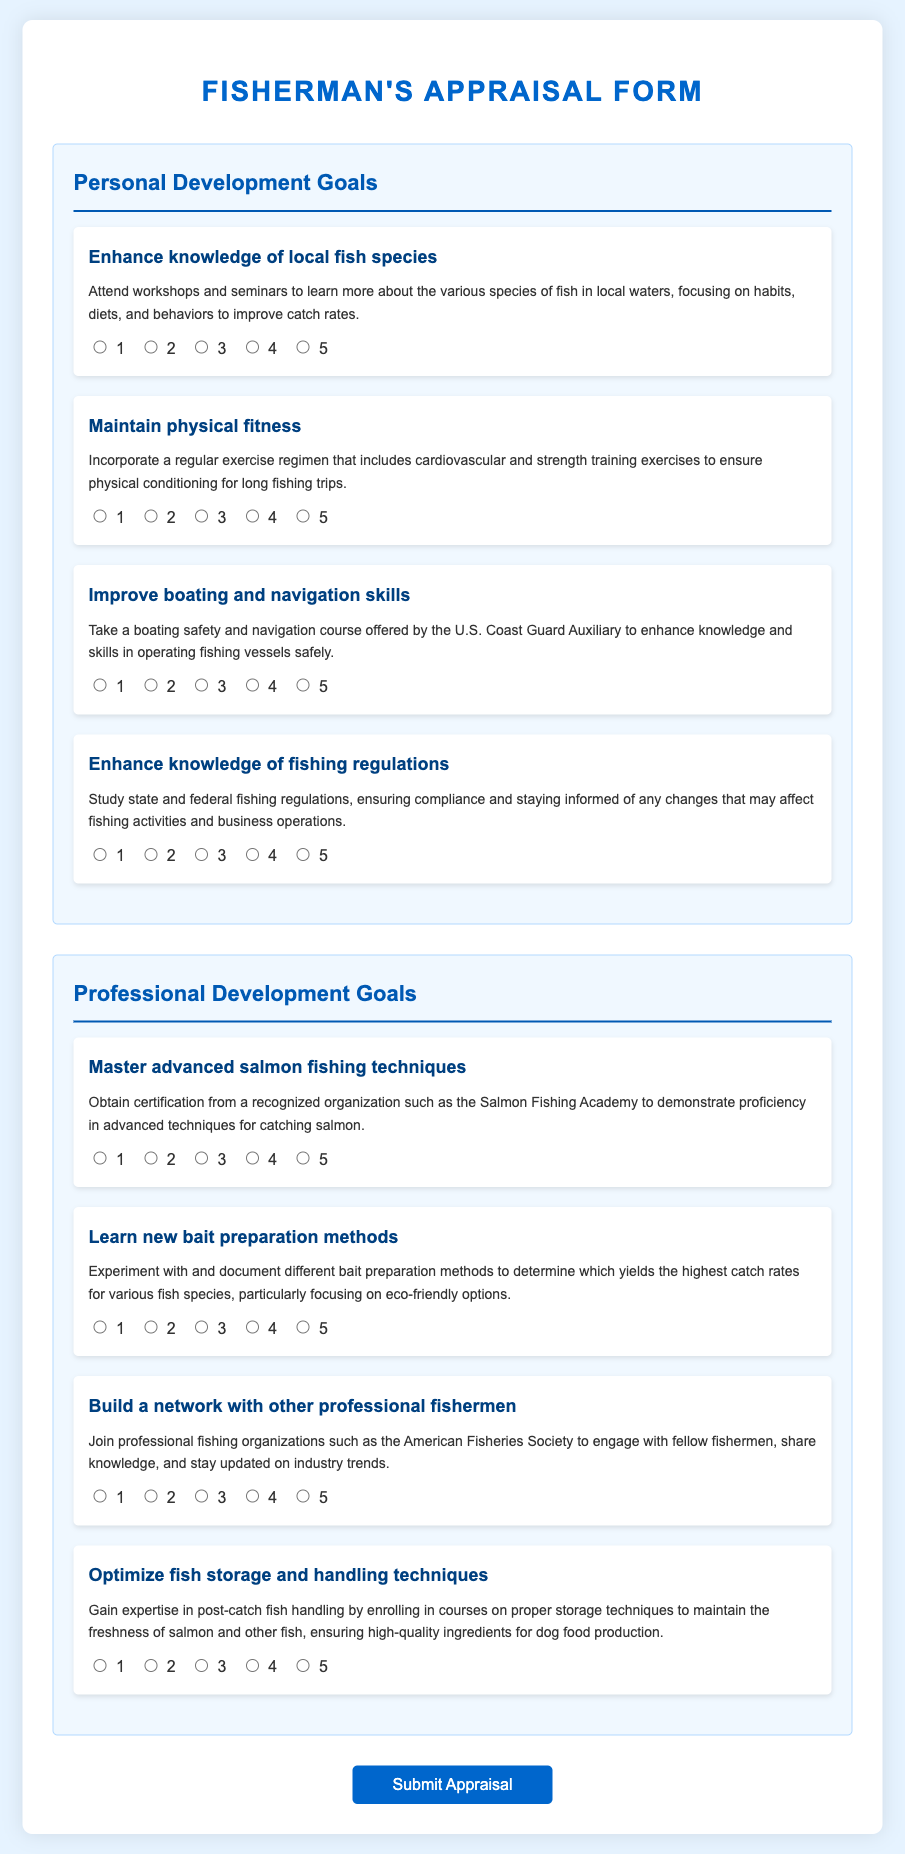what is the title of the form? The title of the form, as indicated at the top of the document, outlines its purpose.
Answer: Fisherman's Appraisal Form how many personal development goals are listed? The section for personal development goals contains a specific number of items that are outlined in the document.
Answer: 4 what is the goal related to physical fitness? The document specifies a goal aimed at maintaining physical fitness, described clearly in the personal development section.
Answer: Maintain physical fitness which organization is mentioned for salmon fishing certification? A specific organization is suggested for obtaining certification in advanced salmon fishing techniques.
Answer: Salmon Fishing Academy what is the focus of the goal about bait preparation? This goal outlines a specific area of experimentation that relates to fishing practices.
Answer: eco-friendly options how many professional development goals are listed? The professional development section similarly has a defined number of goals noted in the document.
Answer: 4 what is the main purpose of the goal to optimize fish storage? This goal emphasizes enhancing practices that contribute to a specific aspect of food quality for dog food production.
Answer: maintain freshness which skill is emphasized in the goal related to boating? The goal specifies a skill set that needs improvement for better fishing practices.
Answer: navigation what type of organizations should a fisherman consider joining? The document suggests engaging with a certain type of organization for professional networking.
Answer: professional fishing organizations 